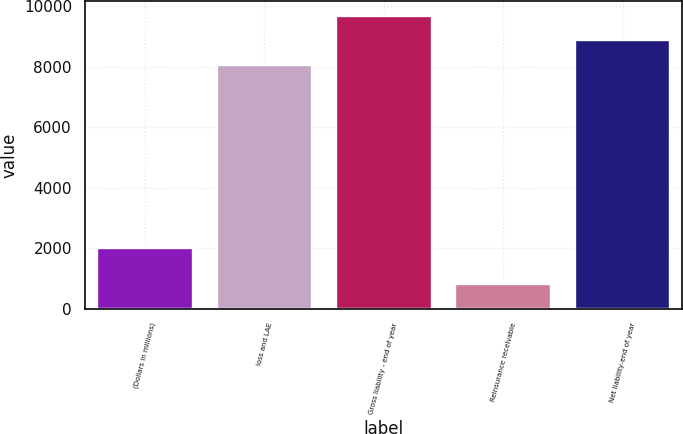Convert chart. <chart><loc_0><loc_0><loc_500><loc_500><bar_chart><fcel>(Dollars in millions)<fcel>loss and LAE<fcel>Gross liability - end of year<fcel>Reinsurance receivable<fcel>Net liability-end of year<nl><fcel>2006<fcel>8078.9<fcel>9694.68<fcel>809.1<fcel>8886.79<nl></chart> 